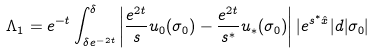Convert formula to latex. <formula><loc_0><loc_0><loc_500><loc_500>\Lambda _ { 1 } = e ^ { - t } \int _ { \delta e ^ { - 2 t } } ^ { \delta } \left | \frac { e ^ { 2 t } } { s } u _ { 0 } ( \sigma _ { 0 } ) - \frac { e ^ { 2 t } } { s ^ { * } } u _ { * } ( \sigma _ { 0 } ) \right | | e ^ { s ^ { * } \hat { x } } | d | \sigma _ { 0 } |</formula> 